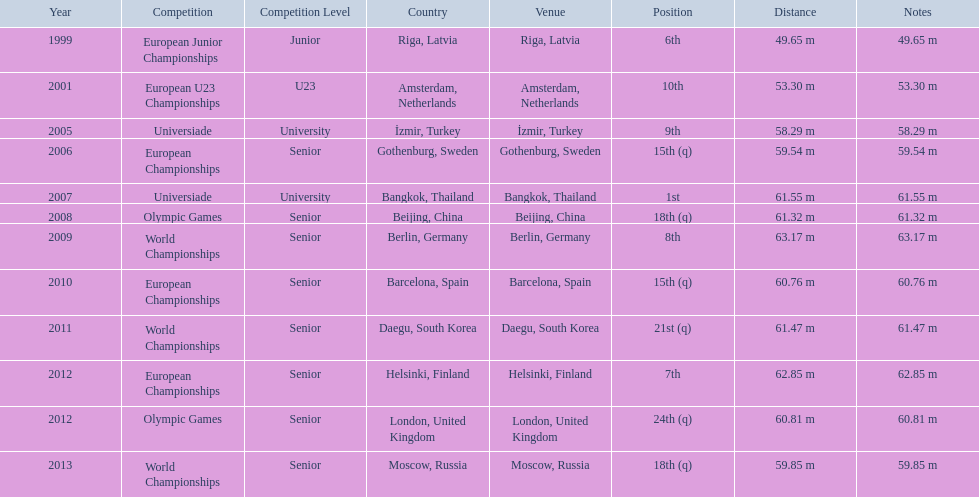What are the years that gerhard mayer participated? 1999, 2001, 2005, 2006, 2007, 2008, 2009, 2010, 2011, 2012, 2012, 2013. Which years were earlier than 2007? 1999, 2001, 2005, 2006. What was the best placing for these years? 6th. 